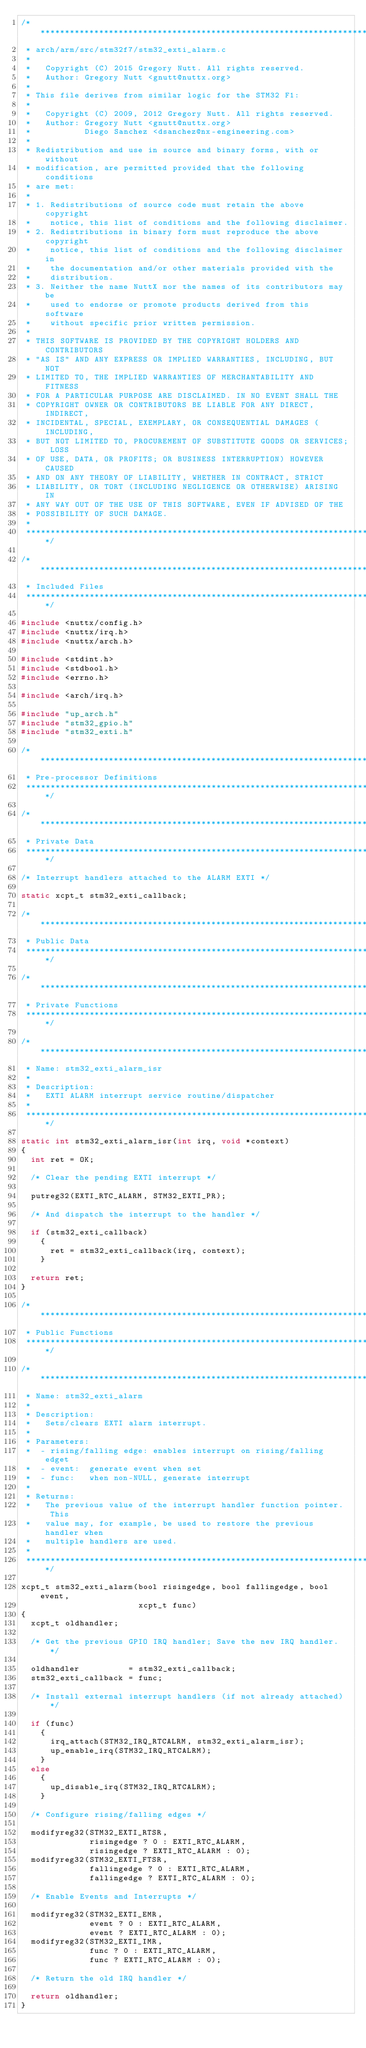<code> <loc_0><loc_0><loc_500><loc_500><_C_>/****************************************************************************
 * arch/arm/src/stm32f7/stm32_exti_alarm.c
 *
 *   Copyright (C) 2015 Gregory Nutt. All rights reserved.
 *   Author: Gregory Nutt <gnutt@nuttx.org>
 *
 * This file derives from similar logic for the STM32 F1:
 *
 *   Copyright (C) 2009, 2012 Gregory Nutt. All rights reserved.
 *   Author: Gregory Nutt <gnutt@nuttx.org>
 *           Diego Sanchez <dsanchez@nx-engineering.com>
 *
 * Redistribution and use in source and binary forms, with or without
 * modification, are permitted provided that the following conditions
 * are met:
 *
 * 1. Redistributions of source code must retain the above copyright
 *    notice, this list of conditions and the following disclaimer.
 * 2. Redistributions in binary form must reproduce the above copyright
 *    notice, this list of conditions and the following disclaimer in
 *    the documentation and/or other materials provided with the
 *    distribution.
 * 3. Neither the name NuttX nor the names of its contributors may be
 *    used to endorse or promote products derived from this software
 *    without specific prior written permission.
 *
 * THIS SOFTWARE IS PROVIDED BY THE COPYRIGHT HOLDERS AND CONTRIBUTORS
 * "AS IS" AND ANY EXPRESS OR IMPLIED WARRANTIES, INCLUDING, BUT NOT
 * LIMITED TO, THE IMPLIED WARRANTIES OF MERCHANTABILITY AND FITNESS
 * FOR A PARTICULAR PURPOSE ARE DISCLAIMED. IN NO EVENT SHALL THE
 * COPYRIGHT OWNER OR CONTRIBUTORS BE LIABLE FOR ANY DIRECT, INDIRECT,
 * INCIDENTAL, SPECIAL, EXEMPLARY, OR CONSEQUENTIAL DAMAGES (INCLUDING,
 * BUT NOT LIMITED TO, PROCUREMENT OF SUBSTITUTE GOODS OR SERVICES; LOSS
 * OF USE, DATA, OR PROFITS; OR BUSINESS INTERRUPTION) HOWEVER CAUSED
 * AND ON ANY THEORY OF LIABILITY, WHETHER IN CONTRACT, STRICT
 * LIABILITY, OR TORT (INCLUDING NEGLIGENCE OR OTHERWISE) ARISING IN
 * ANY WAY OUT OF THE USE OF THIS SOFTWARE, EVEN IF ADVISED OF THE
 * POSSIBILITY OF SUCH DAMAGE.
 *
 ****************************************************************************/

/****************************************************************************
 * Included Files
 ****************************************************************************/

#include <nuttx/config.h>
#include <nuttx/irq.h>
#include <nuttx/arch.h>

#include <stdint.h>
#include <stdbool.h>
#include <errno.h>

#include <arch/irq.h>

#include "up_arch.h"
#include "stm32_gpio.h"
#include "stm32_exti.h"

/****************************************************************************
 * Pre-processor Definitions
 ****************************************************************************/

/****************************************************************************
 * Private Data
 ****************************************************************************/

/* Interrupt handlers attached to the ALARM EXTI */

static xcpt_t stm32_exti_callback;

/****************************************************************************
 * Public Data
 ****************************************************************************/

/****************************************************************************
 * Private Functions
 ****************************************************************************/

/****************************************************************************
 * Name: stm32_exti_alarm_isr
 *
 * Description:
 *   EXTI ALARM interrupt service routine/dispatcher
 *
 ****************************************************************************/

static int stm32_exti_alarm_isr(int irq, void *context)
{
  int ret = OK;

  /* Clear the pending EXTI interrupt */

  putreg32(EXTI_RTC_ALARM, STM32_EXTI_PR);

  /* And dispatch the interrupt to the handler */

  if (stm32_exti_callback)
    {
      ret = stm32_exti_callback(irq, context);
    }

  return ret;
}

/****************************************************************************
 * Public Functions
 ****************************************************************************/

/****************************************************************************
 * Name: stm32_exti_alarm
 *
 * Description:
 *   Sets/clears EXTI alarm interrupt.
 *
 * Parameters:
 *  - rising/falling edge: enables interrupt on rising/falling edget
 *  - event:  generate event when set
 *  - func:   when non-NULL, generate interrupt
 *
 * Returns:
 *   The previous value of the interrupt handler function pointer.  This
 *   value may, for example, be used to restore the previous handler when
 *   multiple handlers are used.
 *
 ****************************************************************************/

xcpt_t stm32_exti_alarm(bool risingedge, bool fallingedge, bool event,
                        xcpt_t func)
{
  xcpt_t oldhandler;

  /* Get the previous GPIO IRQ handler; Save the new IRQ handler. */

  oldhandler          = stm32_exti_callback;
  stm32_exti_callback = func;

  /* Install external interrupt handlers (if not already attached) */

  if (func)
    {
      irq_attach(STM32_IRQ_RTCALRM, stm32_exti_alarm_isr);
      up_enable_irq(STM32_IRQ_RTCALRM);
    }
  else
    {
      up_disable_irq(STM32_IRQ_RTCALRM);
    }

  /* Configure rising/falling edges */

  modifyreg32(STM32_EXTI_RTSR,
              risingedge ? 0 : EXTI_RTC_ALARM,
              risingedge ? EXTI_RTC_ALARM : 0);
  modifyreg32(STM32_EXTI_FTSR,
              fallingedge ? 0 : EXTI_RTC_ALARM,
              fallingedge ? EXTI_RTC_ALARM : 0);

  /* Enable Events and Interrupts */

  modifyreg32(STM32_EXTI_EMR,
              event ? 0 : EXTI_RTC_ALARM,
              event ? EXTI_RTC_ALARM : 0);
  modifyreg32(STM32_EXTI_IMR,
              func ? 0 : EXTI_RTC_ALARM,
              func ? EXTI_RTC_ALARM : 0);

  /* Return the old IRQ handler */

  return oldhandler;
}
</code> 